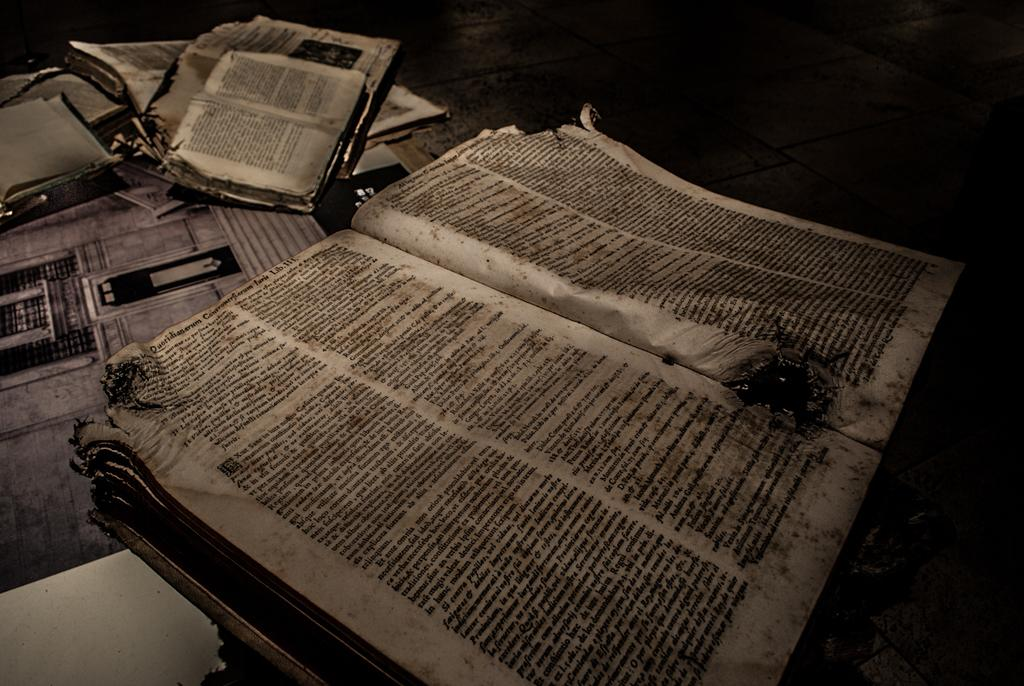<image>
Create a compact narrative representing the image presented. the letters de are in the black and white book 